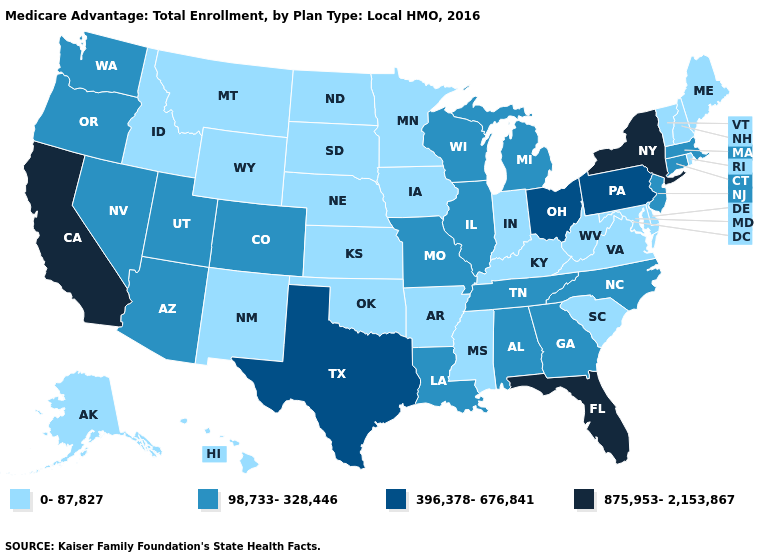What is the highest value in the USA?
Answer briefly. 875,953-2,153,867. Name the states that have a value in the range 98,733-328,446?
Short answer required. Alabama, Arizona, Colorado, Connecticut, Georgia, Illinois, Louisiana, Massachusetts, Michigan, Missouri, North Carolina, New Jersey, Nevada, Oregon, Tennessee, Utah, Washington, Wisconsin. What is the highest value in the USA?
Write a very short answer. 875,953-2,153,867. What is the value of Minnesota?
Be succinct. 0-87,827. Name the states that have a value in the range 0-87,827?
Keep it brief. Alaska, Arkansas, Delaware, Hawaii, Iowa, Idaho, Indiana, Kansas, Kentucky, Maryland, Maine, Minnesota, Mississippi, Montana, North Dakota, Nebraska, New Hampshire, New Mexico, Oklahoma, Rhode Island, South Carolina, South Dakota, Virginia, Vermont, West Virginia, Wyoming. Does Idaho have the lowest value in the USA?
Concise answer only. Yes. Does California have the highest value in the USA?
Keep it brief. Yes. What is the highest value in states that border Georgia?
Give a very brief answer. 875,953-2,153,867. Does Washington have the highest value in the West?
Be succinct. No. Is the legend a continuous bar?
Concise answer only. No. Which states have the highest value in the USA?
Keep it brief. California, Florida, New York. What is the value of Idaho?
Be succinct. 0-87,827. Does Nevada have a higher value than Pennsylvania?
Write a very short answer. No. What is the highest value in states that border Delaware?
Write a very short answer. 396,378-676,841. Does Iowa have the lowest value in the USA?
Give a very brief answer. Yes. 